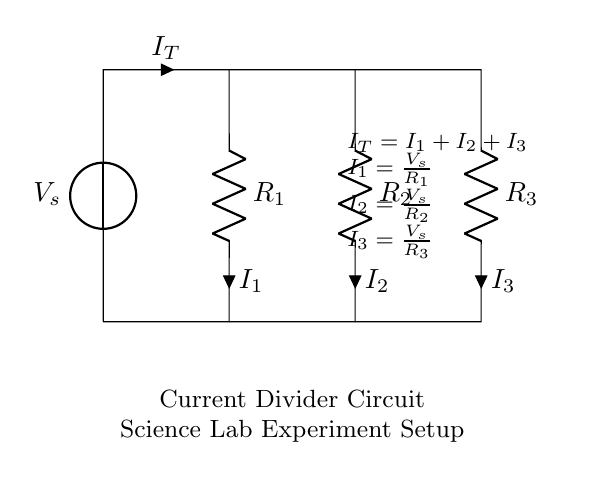What is the voltage source in this circuit? The voltage source is labeled as V_s, which provides the necessary electrical energy for the circuit.
Answer: V_s What is the total current in this circuit? The total current is represented by I_T, which is the sum of all the individual currents flowing through the parallel resistors.
Answer: I_T How many resistors are connected in parallel? There are three resistors labeled R_1, R_2, and R_3 connected in parallel in the circuit.
Answer: Three What is the formula for current flowing through resistor R_1? The current through R_1 is given by the equation I_1 = V_s / R_1, which uses the voltage source and the resistance value.
Answer: I_1 = V_s / R_1 If R_2 is smaller than R_1, how does that affect the current I_2? Since current divides inversely with resistance in parallel circuits, a smaller R_2 results in a larger I_2, as more current flows through the path with lower resistance.
Answer: I_2 increases What is the relationship between I_1, I_2, and I_3? The relationship is defined by the current divider principle, where I_T = I_1 + I_2 + I_3, indicating that the total current is the sum of currents through each resistor.
Answer: I_T = I_1 + I_2 + I_3 In what scenario would I_3 be the largest current among the three? I_3 would be the largest when R_3 is the smallest of the three resistors, allowing more current to flow through it according to the current divider rule.
Answer: When R_3 is smallest 